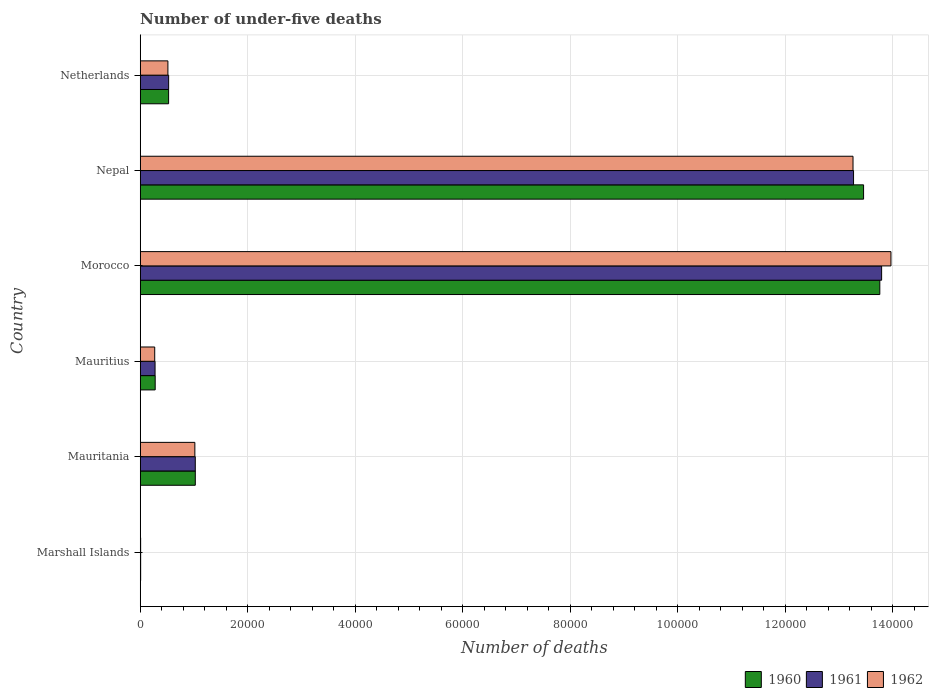How many different coloured bars are there?
Keep it short and to the point. 3. Are the number of bars per tick equal to the number of legend labels?
Give a very brief answer. Yes. How many bars are there on the 1st tick from the top?
Make the answer very short. 3. How many bars are there on the 2nd tick from the bottom?
Keep it short and to the point. 3. What is the label of the 4th group of bars from the top?
Your answer should be compact. Mauritius. Across all countries, what is the maximum number of under-five deaths in 1960?
Ensure brevity in your answer.  1.38e+05. Across all countries, what is the minimum number of under-five deaths in 1961?
Ensure brevity in your answer.  79. In which country was the number of under-five deaths in 1961 maximum?
Ensure brevity in your answer.  Morocco. In which country was the number of under-five deaths in 1960 minimum?
Keep it short and to the point. Marshall Islands. What is the total number of under-five deaths in 1962 in the graph?
Your response must be concise. 2.90e+05. What is the difference between the number of under-five deaths in 1960 in Mauritius and that in Morocco?
Ensure brevity in your answer.  -1.35e+05. What is the difference between the number of under-five deaths in 1961 in Netherlands and the number of under-five deaths in 1962 in Mauritania?
Your response must be concise. -4878. What is the average number of under-five deaths in 1962 per country?
Offer a terse response. 4.84e+04. What is the difference between the number of under-five deaths in 1960 and number of under-five deaths in 1961 in Nepal?
Your answer should be very brief. 1868. What is the ratio of the number of under-five deaths in 1962 in Marshall Islands to that in Mauritius?
Ensure brevity in your answer.  0.03. Is the number of under-five deaths in 1962 in Mauritius less than that in Nepal?
Your answer should be very brief. Yes. What is the difference between the highest and the second highest number of under-five deaths in 1961?
Your response must be concise. 5227. What is the difference between the highest and the lowest number of under-five deaths in 1961?
Provide a succinct answer. 1.38e+05. Is it the case that in every country, the sum of the number of under-five deaths in 1962 and number of under-five deaths in 1960 is greater than the number of under-five deaths in 1961?
Make the answer very short. Yes. How many bars are there?
Ensure brevity in your answer.  18. How many countries are there in the graph?
Give a very brief answer. 6. What is the difference between two consecutive major ticks on the X-axis?
Ensure brevity in your answer.  2.00e+04. Are the values on the major ticks of X-axis written in scientific E-notation?
Offer a very short reply. No. Where does the legend appear in the graph?
Make the answer very short. Bottom right. How many legend labels are there?
Provide a short and direct response. 3. How are the legend labels stacked?
Your answer should be compact. Horizontal. What is the title of the graph?
Offer a terse response. Number of under-five deaths. Does "2000" appear as one of the legend labels in the graph?
Offer a terse response. No. What is the label or title of the X-axis?
Make the answer very short. Number of deaths. What is the Number of deaths of 1960 in Marshall Islands?
Your answer should be compact. 81. What is the Number of deaths in 1961 in Marshall Islands?
Give a very brief answer. 79. What is the Number of deaths of 1960 in Mauritania?
Your response must be concise. 1.02e+04. What is the Number of deaths of 1961 in Mauritania?
Provide a succinct answer. 1.02e+04. What is the Number of deaths of 1962 in Mauritania?
Your answer should be compact. 1.02e+04. What is the Number of deaths in 1960 in Mauritius?
Provide a succinct answer. 2785. What is the Number of deaths of 1961 in Mauritius?
Provide a succinct answer. 2762. What is the Number of deaths in 1962 in Mauritius?
Ensure brevity in your answer.  2697. What is the Number of deaths of 1960 in Morocco?
Ensure brevity in your answer.  1.38e+05. What is the Number of deaths of 1961 in Morocco?
Your answer should be compact. 1.38e+05. What is the Number of deaths of 1962 in Morocco?
Your answer should be very brief. 1.40e+05. What is the Number of deaths of 1960 in Nepal?
Ensure brevity in your answer.  1.35e+05. What is the Number of deaths in 1961 in Nepal?
Make the answer very short. 1.33e+05. What is the Number of deaths of 1962 in Nepal?
Your answer should be very brief. 1.33e+05. What is the Number of deaths of 1960 in Netherlands?
Your answer should be very brief. 5281. What is the Number of deaths in 1961 in Netherlands?
Offer a very short reply. 5288. What is the Number of deaths of 1962 in Netherlands?
Your answer should be compact. 5152. Across all countries, what is the maximum Number of deaths of 1960?
Your answer should be very brief. 1.38e+05. Across all countries, what is the maximum Number of deaths of 1961?
Your response must be concise. 1.38e+05. Across all countries, what is the maximum Number of deaths in 1962?
Offer a very short reply. 1.40e+05. Across all countries, what is the minimum Number of deaths of 1960?
Make the answer very short. 81. Across all countries, what is the minimum Number of deaths in 1961?
Provide a short and direct response. 79. Across all countries, what is the minimum Number of deaths in 1962?
Offer a terse response. 78. What is the total Number of deaths of 1960 in the graph?
Provide a short and direct response. 2.91e+05. What is the total Number of deaths in 1961 in the graph?
Keep it short and to the point. 2.89e+05. What is the total Number of deaths of 1962 in the graph?
Provide a succinct answer. 2.90e+05. What is the difference between the Number of deaths in 1960 in Marshall Islands and that in Mauritania?
Give a very brief answer. -1.02e+04. What is the difference between the Number of deaths in 1961 in Marshall Islands and that in Mauritania?
Keep it short and to the point. -1.02e+04. What is the difference between the Number of deaths in 1962 in Marshall Islands and that in Mauritania?
Make the answer very short. -1.01e+04. What is the difference between the Number of deaths in 1960 in Marshall Islands and that in Mauritius?
Give a very brief answer. -2704. What is the difference between the Number of deaths in 1961 in Marshall Islands and that in Mauritius?
Make the answer very short. -2683. What is the difference between the Number of deaths in 1962 in Marshall Islands and that in Mauritius?
Ensure brevity in your answer.  -2619. What is the difference between the Number of deaths in 1960 in Marshall Islands and that in Morocco?
Keep it short and to the point. -1.38e+05. What is the difference between the Number of deaths of 1961 in Marshall Islands and that in Morocco?
Keep it short and to the point. -1.38e+05. What is the difference between the Number of deaths of 1962 in Marshall Islands and that in Morocco?
Offer a terse response. -1.40e+05. What is the difference between the Number of deaths of 1960 in Marshall Islands and that in Nepal?
Keep it short and to the point. -1.35e+05. What is the difference between the Number of deaths of 1961 in Marshall Islands and that in Nepal?
Keep it short and to the point. -1.33e+05. What is the difference between the Number of deaths of 1962 in Marshall Islands and that in Nepal?
Provide a succinct answer. -1.33e+05. What is the difference between the Number of deaths in 1960 in Marshall Islands and that in Netherlands?
Offer a terse response. -5200. What is the difference between the Number of deaths of 1961 in Marshall Islands and that in Netherlands?
Your response must be concise. -5209. What is the difference between the Number of deaths of 1962 in Marshall Islands and that in Netherlands?
Offer a very short reply. -5074. What is the difference between the Number of deaths in 1960 in Mauritania and that in Mauritius?
Give a very brief answer. 7463. What is the difference between the Number of deaths of 1961 in Mauritania and that in Mauritius?
Keep it short and to the point. 7483. What is the difference between the Number of deaths in 1962 in Mauritania and that in Mauritius?
Provide a short and direct response. 7469. What is the difference between the Number of deaths in 1960 in Mauritania and that in Morocco?
Offer a terse response. -1.27e+05. What is the difference between the Number of deaths of 1961 in Mauritania and that in Morocco?
Keep it short and to the point. -1.28e+05. What is the difference between the Number of deaths in 1962 in Mauritania and that in Morocco?
Your answer should be compact. -1.30e+05. What is the difference between the Number of deaths in 1960 in Mauritania and that in Nepal?
Make the answer very short. -1.24e+05. What is the difference between the Number of deaths of 1961 in Mauritania and that in Nepal?
Make the answer very short. -1.22e+05. What is the difference between the Number of deaths in 1962 in Mauritania and that in Nepal?
Ensure brevity in your answer.  -1.22e+05. What is the difference between the Number of deaths of 1960 in Mauritania and that in Netherlands?
Ensure brevity in your answer.  4967. What is the difference between the Number of deaths of 1961 in Mauritania and that in Netherlands?
Your answer should be very brief. 4957. What is the difference between the Number of deaths of 1962 in Mauritania and that in Netherlands?
Keep it short and to the point. 5014. What is the difference between the Number of deaths of 1960 in Mauritius and that in Morocco?
Provide a short and direct response. -1.35e+05. What is the difference between the Number of deaths of 1961 in Mauritius and that in Morocco?
Offer a very short reply. -1.35e+05. What is the difference between the Number of deaths in 1962 in Mauritius and that in Morocco?
Your answer should be very brief. -1.37e+05. What is the difference between the Number of deaths of 1960 in Mauritius and that in Nepal?
Your response must be concise. -1.32e+05. What is the difference between the Number of deaths in 1961 in Mauritius and that in Nepal?
Give a very brief answer. -1.30e+05. What is the difference between the Number of deaths of 1962 in Mauritius and that in Nepal?
Keep it short and to the point. -1.30e+05. What is the difference between the Number of deaths in 1960 in Mauritius and that in Netherlands?
Keep it short and to the point. -2496. What is the difference between the Number of deaths of 1961 in Mauritius and that in Netherlands?
Provide a short and direct response. -2526. What is the difference between the Number of deaths of 1962 in Mauritius and that in Netherlands?
Offer a terse response. -2455. What is the difference between the Number of deaths of 1960 in Morocco and that in Nepal?
Offer a terse response. 3019. What is the difference between the Number of deaths in 1961 in Morocco and that in Nepal?
Provide a succinct answer. 5227. What is the difference between the Number of deaths of 1962 in Morocco and that in Nepal?
Ensure brevity in your answer.  7061. What is the difference between the Number of deaths in 1960 in Morocco and that in Netherlands?
Make the answer very short. 1.32e+05. What is the difference between the Number of deaths of 1961 in Morocco and that in Netherlands?
Give a very brief answer. 1.33e+05. What is the difference between the Number of deaths in 1962 in Morocco and that in Netherlands?
Your answer should be compact. 1.35e+05. What is the difference between the Number of deaths of 1960 in Nepal and that in Netherlands?
Ensure brevity in your answer.  1.29e+05. What is the difference between the Number of deaths of 1961 in Nepal and that in Netherlands?
Ensure brevity in your answer.  1.27e+05. What is the difference between the Number of deaths in 1962 in Nepal and that in Netherlands?
Your answer should be very brief. 1.27e+05. What is the difference between the Number of deaths of 1960 in Marshall Islands and the Number of deaths of 1961 in Mauritania?
Your response must be concise. -1.02e+04. What is the difference between the Number of deaths in 1960 in Marshall Islands and the Number of deaths in 1962 in Mauritania?
Your response must be concise. -1.01e+04. What is the difference between the Number of deaths of 1961 in Marshall Islands and the Number of deaths of 1962 in Mauritania?
Offer a very short reply. -1.01e+04. What is the difference between the Number of deaths of 1960 in Marshall Islands and the Number of deaths of 1961 in Mauritius?
Offer a terse response. -2681. What is the difference between the Number of deaths of 1960 in Marshall Islands and the Number of deaths of 1962 in Mauritius?
Your response must be concise. -2616. What is the difference between the Number of deaths in 1961 in Marshall Islands and the Number of deaths in 1962 in Mauritius?
Your response must be concise. -2618. What is the difference between the Number of deaths of 1960 in Marshall Islands and the Number of deaths of 1961 in Morocco?
Your answer should be compact. -1.38e+05. What is the difference between the Number of deaths in 1960 in Marshall Islands and the Number of deaths in 1962 in Morocco?
Your answer should be compact. -1.40e+05. What is the difference between the Number of deaths of 1961 in Marshall Islands and the Number of deaths of 1962 in Morocco?
Keep it short and to the point. -1.40e+05. What is the difference between the Number of deaths in 1960 in Marshall Islands and the Number of deaths in 1961 in Nepal?
Your response must be concise. -1.33e+05. What is the difference between the Number of deaths in 1960 in Marshall Islands and the Number of deaths in 1962 in Nepal?
Your answer should be compact. -1.33e+05. What is the difference between the Number of deaths of 1961 in Marshall Islands and the Number of deaths of 1962 in Nepal?
Ensure brevity in your answer.  -1.33e+05. What is the difference between the Number of deaths of 1960 in Marshall Islands and the Number of deaths of 1961 in Netherlands?
Keep it short and to the point. -5207. What is the difference between the Number of deaths of 1960 in Marshall Islands and the Number of deaths of 1962 in Netherlands?
Offer a very short reply. -5071. What is the difference between the Number of deaths in 1961 in Marshall Islands and the Number of deaths in 1962 in Netherlands?
Keep it short and to the point. -5073. What is the difference between the Number of deaths in 1960 in Mauritania and the Number of deaths in 1961 in Mauritius?
Your answer should be compact. 7486. What is the difference between the Number of deaths in 1960 in Mauritania and the Number of deaths in 1962 in Mauritius?
Offer a terse response. 7551. What is the difference between the Number of deaths of 1961 in Mauritania and the Number of deaths of 1962 in Mauritius?
Provide a succinct answer. 7548. What is the difference between the Number of deaths in 1960 in Mauritania and the Number of deaths in 1961 in Morocco?
Provide a short and direct response. -1.28e+05. What is the difference between the Number of deaths in 1960 in Mauritania and the Number of deaths in 1962 in Morocco?
Give a very brief answer. -1.29e+05. What is the difference between the Number of deaths of 1961 in Mauritania and the Number of deaths of 1962 in Morocco?
Provide a short and direct response. -1.29e+05. What is the difference between the Number of deaths in 1960 in Mauritania and the Number of deaths in 1961 in Nepal?
Provide a short and direct response. -1.22e+05. What is the difference between the Number of deaths in 1960 in Mauritania and the Number of deaths in 1962 in Nepal?
Make the answer very short. -1.22e+05. What is the difference between the Number of deaths of 1961 in Mauritania and the Number of deaths of 1962 in Nepal?
Keep it short and to the point. -1.22e+05. What is the difference between the Number of deaths of 1960 in Mauritania and the Number of deaths of 1961 in Netherlands?
Provide a short and direct response. 4960. What is the difference between the Number of deaths in 1960 in Mauritania and the Number of deaths in 1962 in Netherlands?
Offer a terse response. 5096. What is the difference between the Number of deaths in 1961 in Mauritania and the Number of deaths in 1962 in Netherlands?
Your answer should be very brief. 5093. What is the difference between the Number of deaths of 1960 in Mauritius and the Number of deaths of 1961 in Morocco?
Give a very brief answer. -1.35e+05. What is the difference between the Number of deaths in 1960 in Mauritius and the Number of deaths in 1962 in Morocco?
Offer a very short reply. -1.37e+05. What is the difference between the Number of deaths in 1961 in Mauritius and the Number of deaths in 1962 in Morocco?
Give a very brief answer. -1.37e+05. What is the difference between the Number of deaths of 1960 in Mauritius and the Number of deaths of 1961 in Nepal?
Your answer should be very brief. -1.30e+05. What is the difference between the Number of deaths of 1960 in Mauritius and the Number of deaths of 1962 in Nepal?
Your answer should be compact. -1.30e+05. What is the difference between the Number of deaths in 1961 in Mauritius and the Number of deaths in 1962 in Nepal?
Provide a short and direct response. -1.30e+05. What is the difference between the Number of deaths in 1960 in Mauritius and the Number of deaths in 1961 in Netherlands?
Make the answer very short. -2503. What is the difference between the Number of deaths of 1960 in Mauritius and the Number of deaths of 1962 in Netherlands?
Provide a short and direct response. -2367. What is the difference between the Number of deaths in 1961 in Mauritius and the Number of deaths in 1962 in Netherlands?
Ensure brevity in your answer.  -2390. What is the difference between the Number of deaths of 1960 in Morocco and the Number of deaths of 1961 in Nepal?
Your answer should be compact. 4887. What is the difference between the Number of deaths of 1960 in Morocco and the Number of deaths of 1962 in Nepal?
Provide a succinct answer. 4986. What is the difference between the Number of deaths of 1961 in Morocco and the Number of deaths of 1962 in Nepal?
Provide a short and direct response. 5326. What is the difference between the Number of deaths of 1960 in Morocco and the Number of deaths of 1961 in Netherlands?
Your answer should be compact. 1.32e+05. What is the difference between the Number of deaths in 1960 in Morocco and the Number of deaths in 1962 in Netherlands?
Provide a succinct answer. 1.32e+05. What is the difference between the Number of deaths in 1961 in Morocco and the Number of deaths in 1962 in Netherlands?
Provide a succinct answer. 1.33e+05. What is the difference between the Number of deaths of 1960 in Nepal and the Number of deaths of 1961 in Netherlands?
Your answer should be compact. 1.29e+05. What is the difference between the Number of deaths in 1960 in Nepal and the Number of deaths in 1962 in Netherlands?
Ensure brevity in your answer.  1.29e+05. What is the difference between the Number of deaths of 1961 in Nepal and the Number of deaths of 1962 in Netherlands?
Keep it short and to the point. 1.28e+05. What is the average Number of deaths of 1960 per country?
Offer a terse response. 4.84e+04. What is the average Number of deaths of 1961 per country?
Make the answer very short. 4.82e+04. What is the average Number of deaths of 1962 per country?
Your answer should be very brief. 4.84e+04. What is the difference between the Number of deaths of 1960 and Number of deaths of 1962 in Marshall Islands?
Your response must be concise. 3. What is the difference between the Number of deaths in 1961 and Number of deaths in 1962 in Marshall Islands?
Give a very brief answer. 1. What is the difference between the Number of deaths of 1960 and Number of deaths of 1961 in Mauritania?
Your answer should be compact. 3. What is the difference between the Number of deaths in 1960 and Number of deaths in 1962 in Mauritania?
Keep it short and to the point. 82. What is the difference between the Number of deaths of 1961 and Number of deaths of 1962 in Mauritania?
Keep it short and to the point. 79. What is the difference between the Number of deaths in 1960 and Number of deaths in 1961 in Mauritius?
Keep it short and to the point. 23. What is the difference between the Number of deaths of 1960 and Number of deaths of 1961 in Morocco?
Provide a short and direct response. -340. What is the difference between the Number of deaths of 1960 and Number of deaths of 1962 in Morocco?
Offer a terse response. -2075. What is the difference between the Number of deaths of 1961 and Number of deaths of 1962 in Morocco?
Your answer should be compact. -1735. What is the difference between the Number of deaths in 1960 and Number of deaths in 1961 in Nepal?
Keep it short and to the point. 1868. What is the difference between the Number of deaths of 1960 and Number of deaths of 1962 in Nepal?
Offer a terse response. 1967. What is the difference between the Number of deaths in 1960 and Number of deaths in 1962 in Netherlands?
Provide a short and direct response. 129. What is the difference between the Number of deaths in 1961 and Number of deaths in 1962 in Netherlands?
Your response must be concise. 136. What is the ratio of the Number of deaths of 1960 in Marshall Islands to that in Mauritania?
Make the answer very short. 0.01. What is the ratio of the Number of deaths in 1961 in Marshall Islands to that in Mauritania?
Make the answer very short. 0.01. What is the ratio of the Number of deaths in 1962 in Marshall Islands to that in Mauritania?
Offer a very short reply. 0.01. What is the ratio of the Number of deaths of 1960 in Marshall Islands to that in Mauritius?
Offer a very short reply. 0.03. What is the ratio of the Number of deaths in 1961 in Marshall Islands to that in Mauritius?
Provide a short and direct response. 0.03. What is the ratio of the Number of deaths of 1962 in Marshall Islands to that in Mauritius?
Keep it short and to the point. 0.03. What is the ratio of the Number of deaths in 1960 in Marshall Islands to that in Morocco?
Provide a short and direct response. 0. What is the ratio of the Number of deaths of 1961 in Marshall Islands to that in Morocco?
Your response must be concise. 0. What is the ratio of the Number of deaths in 1962 in Marshall Islands to that in Morocco?
Your response must be concise. 0. What is the ratio of the Number of deaths of 1960 in Marshall Islands to that in Nepal?
Keep it short and to the point. 0. What is the ratio of the Number of deaths of 1961 in Marshall Islands to that in Nepal?
Make the answer very short. 0. What is the ratio of the Number of deaths of 1962 in Marshall Islands to that in Nepal?
Make the answer very short. 0. What is the ratio of the Number of deaths in 1960 in Marshall Islands to that in Netherlands?
Provide a short and direct response. 0.02. What is the ratio of the Number of deaths of 1961 in Marshall Islands to that in Netherlands?
Offer a very short reply. 0.01. What is the ratio of the Number of deaths in 1962 in Marshall Islands to that in Netherlands?
Offer a terse response. 0.02. What is the ratio of the Number of deaths of 1960 in Mauritania to that in Mauritius?
Your response must be concise. 3.68. What is the ratio of the Number of deaths of 1961 in Mauritania to that in Mauritius?
Offer a terse response. 3.71. What is the ratio of the Number of deaths in 1962 in Mauritania to that in Mauritius?
Make the answer very short. 3.77. What is the ratio of the Number of deaths of 1960 in Mauritania to that in Morocco?
Give a very brief answer. 0.07. What is the ratio of the Number of deaths of 1961 in Mauritania to that in Morocco?
Your answer should be compact. 0.07. What is the ratio of the Number of deaths of 1962 in Mauritania to that in Morocco?
Provide a succinct answer. 0.07. What is the ratio of the Number of deaths of 1960 in Mauritania to that in Nepal?
Keep it short and to the point. 0.08. What is the ratio of the Number of deaths in 1961 in Mauritania to that in Nepal?
Your response must be concise. 0.08. What is the ratio of the Number of deaths of 1962 in Mauritania to that in Nepal?
Give a very brief answer. 0.08. What is the ratio of the Number of deaths of 1960 in Mauritania to that in Netherlands?
Your response must be concise. 1.94. What is the ratio of the Number of deaths of 1961 in Mauritania to that in Netherlands?
Keep it short and to the point. 1.94. What is the ratio of the Number of deaths in 1962 in Mauritania to that in Netherlands?
Provide a succinct answer. 1.97. What is the ratio of the Number of deaths of 1960 in Mauritius to that in Morocco?
Your answer should be very brief. 0.02. What is the ratio of the Number of deaths of 1962 in Mauritius to that in Morocco?
Provide a short and direct response. 0.02. What is the ratio of the Number of deaths of 1960 in Mauritius to that in Nepal?
Your answer should be very brief. 0.02. What is the ratio of the Number of deaths in 1961 in Mauritius to that in Nepal?
Provide a succinct answer. 0.02. What is the ratio of the Number of deaths in 1962 in Mauritius to that in Nepal?
Your response must be concise. 0.02. What is the ratio of the Number of deaths in 1960 in Mauritius to that in Netherlands?
Keep it short and to the point. 0.53. What is the ratio of the Number of deaths in 1961 in Mauritius to that in Netherlands?
Your answer should be very brief. 0.52. What is the ratio of the Number of deaths of 1962 in Mauritius to that in Netherlands?
Make the answer very short. 0.52. What is the ratio of the Number of deaths in 1960 in Morocco to that in Nepal?
Make the answer very short. 1.02. What is the ratio of the Number of deaths of 1961 in Morocco to that in Nepal?
Offer a very short reply. 1.04. What is the ratio of the Number of deaths in 1962 in Morocco to that in Nepal?
Ensure brevity in your answer.  1.05. What is the ratio of the Number of deaths in 1960 in Morocco to that in Netherlands?
Your answer should be compact. 26.06. What is the ratio of the Number of deaths of 1961 in Morocco to that in Netherlands?
Offer a very short reply. 26.09. What is the ratio of the Number of deaths of 1962 in Morocco to that in Netherlands?
Give a very brief answer. 27.12. What is the ratio of the Number of deaths in 1960 in Nepal to that in Netherlands?
Your answer should be very brief. 25.49. What is the ratio of the Number of deaths of 1961 in Nepal to that in Netherlands?
Give a very brief answer. 25.1. What is the ratio of the Number of deaths of 1962 in Nepal to that in Netherlands?
Ensure brevity in your answer.  25.75. What is the difference between the highest and the second highest Number of deaths of 1960?
Ensure brevity in your answer.  3019. What is the difference between the highest and the second highest Number of deaths of 1961?
Provide a short and direct response. 5227. What is the difference between the highest and the second highest Number of deaths in 1962?
Offer a very short reply. 7061. What is the difference between the highest and the lowest Number of deaths in 1960?
Offer a terse response. 1.38e+05. What is the difference between the highest and the lowest Number of deaths of 1961?
Your response must be concise. 1.38e+05. What is the difference between the highest and the lowest Number of deaths of 1962?
Make the answer very short. 1.40e+05. 